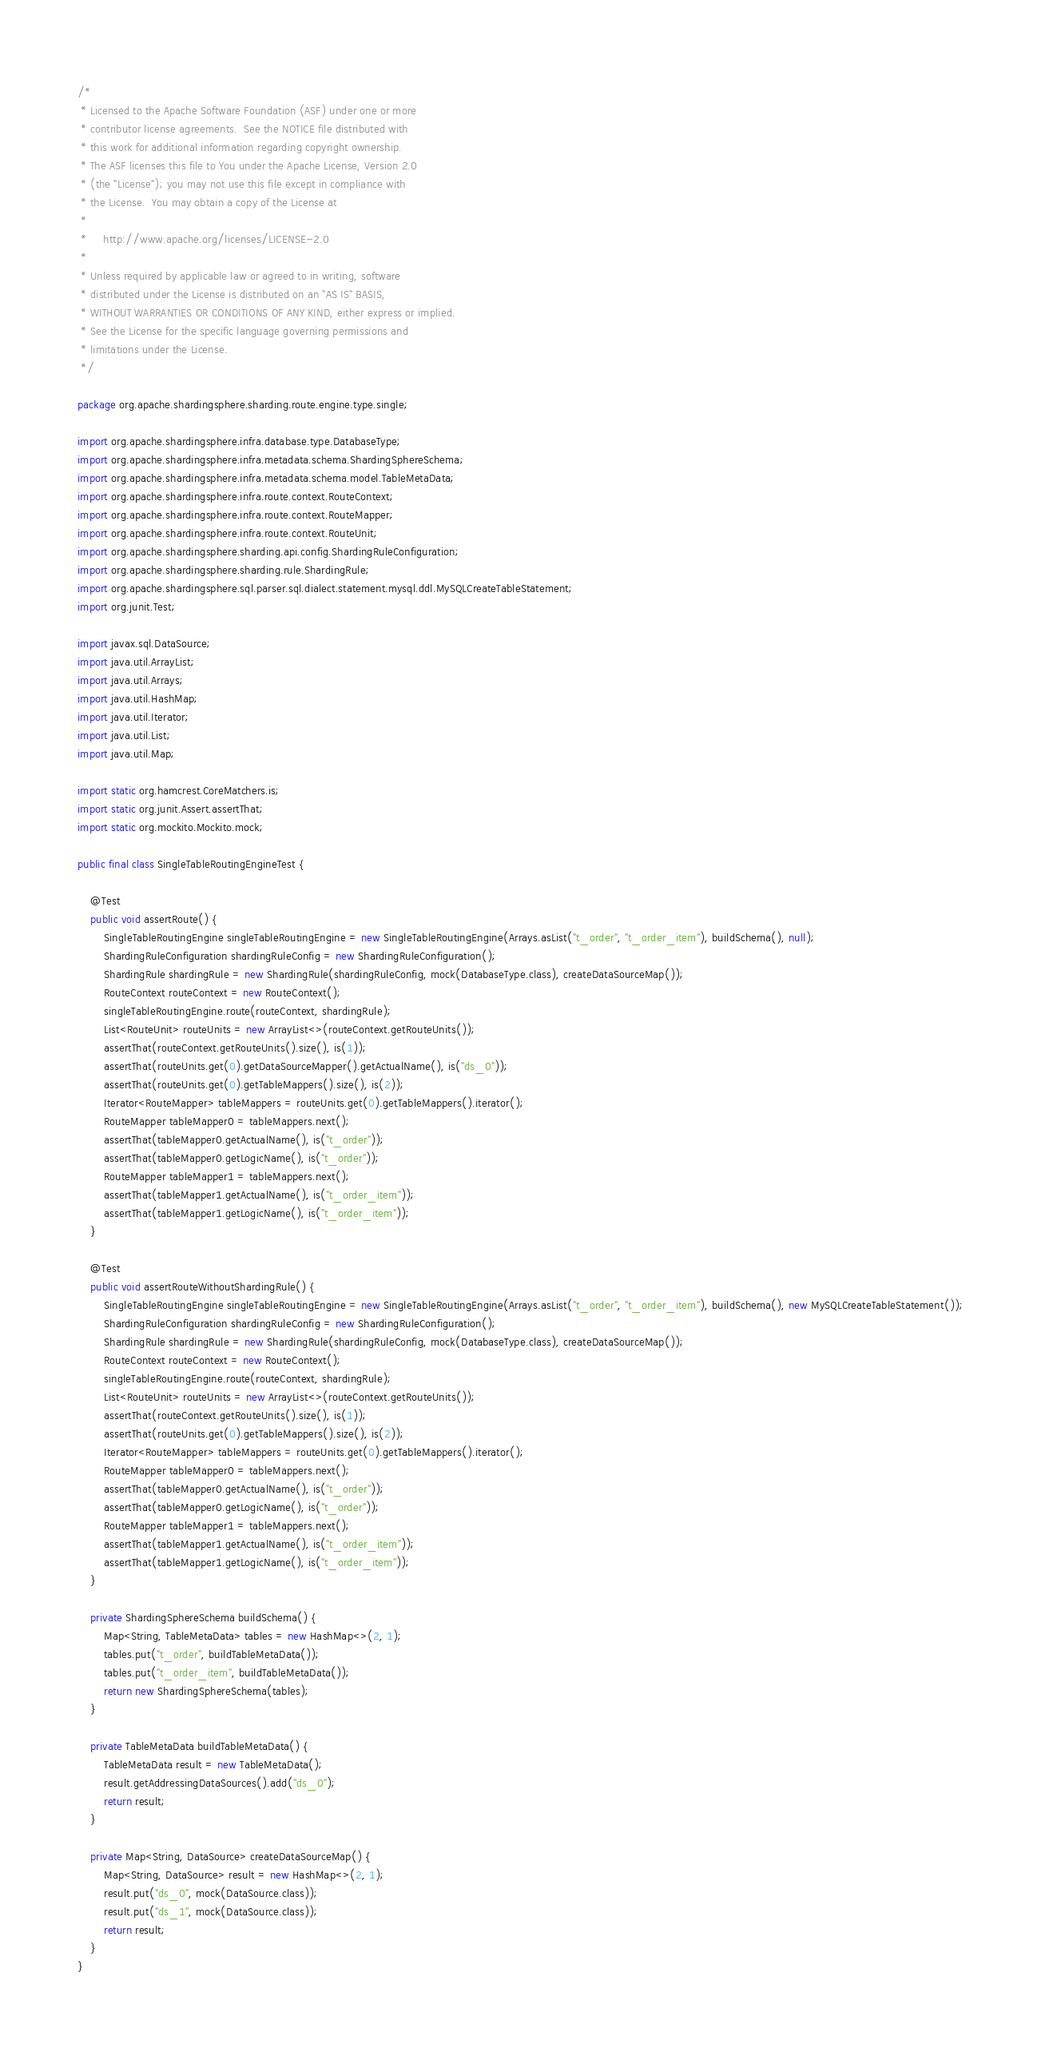<code> <loc_0><loc_0><loc_500><loc_500><_Java_>/*
 * Licensed to the Apache Software Foundation (ASF) under one or more
 * contributor license agreements.  See the NOTICE file distributed with
 * this work for additional information regarding copyright ownership.
 * The ASF licenses this file to You under the Apache License, Version 2.0
 * (the "License"); you may not use this file except in compliance with
 * the License.  You may obtain a copy of the License at
 *
 *     http://www.apache.org/licenses/LICENSE-2.0
 *
 * Unless required by applicable law or agreed to in writing, software
 * distributed under the License is distributed on an "AS IS" BASIS,
 * WITHOUT WARRANTIES OR CONDITIONS OF ANY KIND, either express or implied.
 * See the License for the specific language governing permissions and
 * limitations under the License.
 */

package org.apache.shardingsphere.sharding.route.engine.type.single;

import org.apache.shardingsphere.infra.database.type.DatabaseType;
import org.apache.shardingsphere.infra.metadata.schema.ShardingSphereSchema;
import org.apache.shardingsphere.infra.metadata.schema.model.TableMetaData;
import org.apache.shardingsphere.infra.route.context.RouteContext;
import org.apache.shardingsphere.infra.route.context.RouteMapper;
import org.apache.shardingsphere.infra.route.context.RouteUnit;
import org.apache.shardingsphere.sharding.api.config.ShardingRuleConfiguration;
import org.apache.shardingsphere.sharding.rule.ShardingRule;
import org.apache.shardingsphere.sql.parser.sql.dialect.statement.mysql.ddl.MySQLCreateTableStatement;
import org.junit.Test;

import javax.sql.DataSource;
import java.util.ArrayList;
import java.util.Arrays;
import java.util.HashMap;
import java.util.Iterator;
import java.util.List;
import java.util.Map;

import static org.hamcrest.CoreMatchers.is;
import static org.junit.Assert.assertThat;
import static org.mockito.Mockito.mock;

public final class SingleTableRoutingEngineTest {
    
    @Test
    public void assertRoute() {
        SingleTableRoutingEngine singleTableRoutingEngine = new SingleTableRoutingEngine(Arrays.asList("t_order", "t_order_item"), buildSchema(), null);
        ShardingRuleConfiguration shardingRuleConfig = new ShardingRuleConfiguration();
        ShardingRule shardingRule = new ShardingRule(shardingRuleConfig, mock(DatabaseType.class), createDataSourceMap());
        RouteContext routeContext = new RouteContext();
        singleTableRoutingEngine.route(routeContext, shardingRule);
        List<RouteUnit> routeUnits = new ArrayList<>(routeContext.getRouteUnits());
        assertThat(routeContext.getRouteUnits().size(), is(1));
        assertThat(routeUnits.get(0).getDataSourceMapper().getActualName(), is("ds_0"));
        assertThat(routeUnits.get(0).getTableMappers().size(), is(2));
        Iterator<RouteMapper> tableMappers = routeUnits.get(0).getTableMappers().iterator();
        RouteMapper tableMapper0 = tableMappers.next();
        assertThat(tableMapper0.getActualName(), is("t_order"));
        assertThat(tableMapper0.getLogicName(), is("t_order"));
        RouteMapper tableMapper1 = tableMappers.next();
        assertThat(tableMapper1.getActualName(), is("t_order_item"));
        assertThat(tableMapper1.getLogicName(), is("t_order_item"));
    }
    
    @Test
    public void assertRouteWithoutShardingRule() {
        SingleTableRoutingEngine singleTableRoutingEngine = new SingleTableRoutingEngine(Arrays.asList("t_order", "t_order_item"), buildSchema(), new MySQLCreateTableStatement());
        ShardingRuleConfiguration shardingRuleConfig = new ShardingRuleConfiguration();
        ShardingRule shardingRule = new ShardingRule(shardingRuleConfig, mock(DatabaseType.class), createDataSourceMap());
        RouteContext routeContext = new RouteContext();
        singleTableRoutingEngine.route(routeContext, shardingRule);
        List<RouteUnit> routeUnits = new ArrayList<>(routeContext.getRouteUnits());
        assertThat(routeContext.getRouteUnits().size(), is(1));
        assertThat(routeUnits.get(0).getTableMappers().size(), is(2));
        Iterator<RouteMapper> tableMappers = routeUnits.get(0).getTableMappers().iterator();
        RouteMapper tableMapper0 = tableMappers.next();
        assertThat(tableMapper0.getActualName(), is("t_order"));
        assertThat(tableMapper0.getLogicName(), is("t_order"));
        RouteMapper tableMapper1 = tableMappers.next();
        assertThat(tableMapper1.getActualName(), is("t_order_item"));
        assertThat(tableMapper1.getLogicName(), is("t_order_item"));
    }
    
    private ShardingSphereSchema buildSchema() {
        Map<String, TableMetaData> tables = new HashMap<>(2, 1);
        tables.put("t_order", buildTableMetaData());
        tables.put("t_order_item", buildTableMetaData());
        return new ShardingSphereSchema(tables);
    }
    
    private TableMetaData buildTableMetaData() {
        TableMetaData result = new TableMetaData();
        result.getAddressingDataSources().add("ds_0");
        return result;
    }
    
    private Map<String, DataSource> createDataSourceMap() {
        Map<String, DataSource> result = new HashMap<>(2, 1);
        result.put("ds_0", mock(DataSource.class));
        result.put("ds_1", mock(DataSource.class));
        return result;
    }
}
</code> 